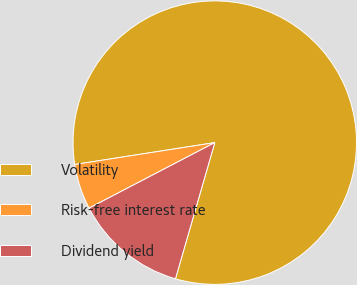<chart> <loc_0><loc_0><loc_500><loc_500><pie_chart><fcel>Volatility<fcel>Risk-free interest rate<fcel>Dividend yield<nl><fcel>81.94%<fcel>5.18%<fcel>12.88%<nl></chart> 